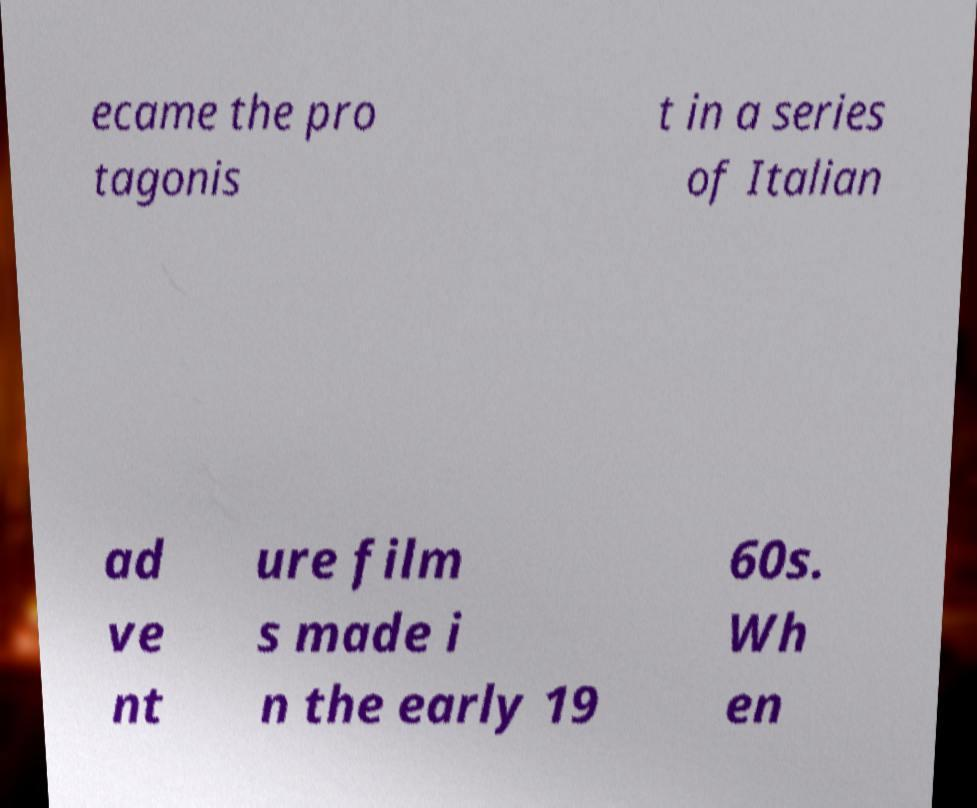What messages or text are displayed in this image? I need them in a readable, typed format. ecame the pro tagonis t in a series of Italian ad ve nt ure film s made i n the early 19 60s. Wh en 